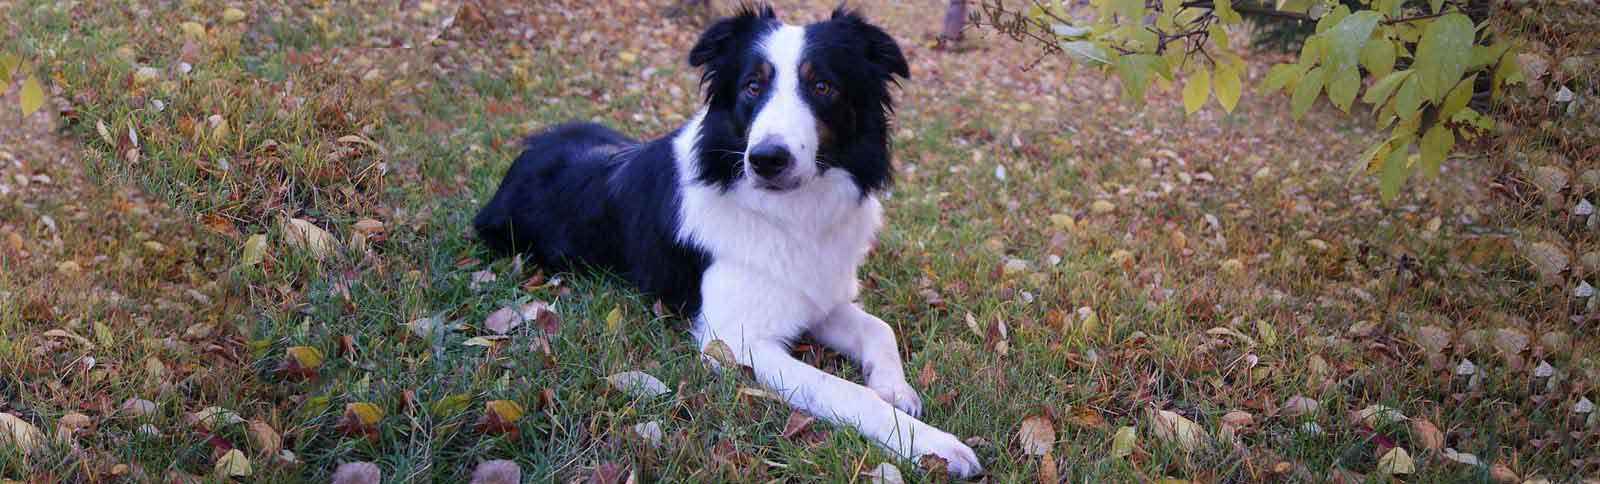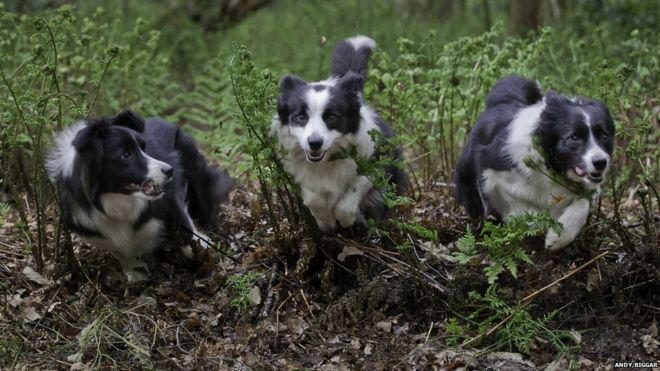The first image is the image on the left, the second image is the image on the right. Evaluate the accuracy of this statement regarding the images: "The left image contains two dogs that are not wearing vests, and the right image features a girl in a striped sweater with at least one dog wearing a vest pack.". Is it true? Answer yes or no. No. The first image is the image on the left, the second image is the image on the right. Examine the images to the left and right. Is the description "One or more of the images has three dogs." accurate? Answer yes or no. Yes. 